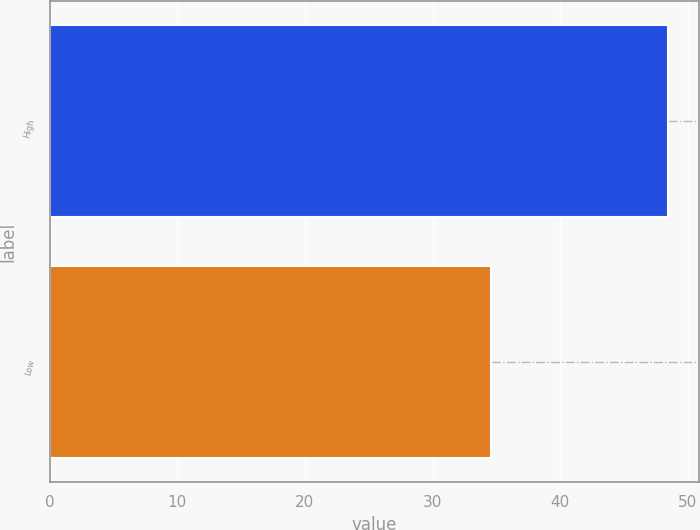Convert chart to OTSL. <chart><loc_0><loc_0><loc_500><loc_500><bar_chart><fcel>High<fcel>Low<nl><fcel>48.46<fcel>34.6<nl></chart> 